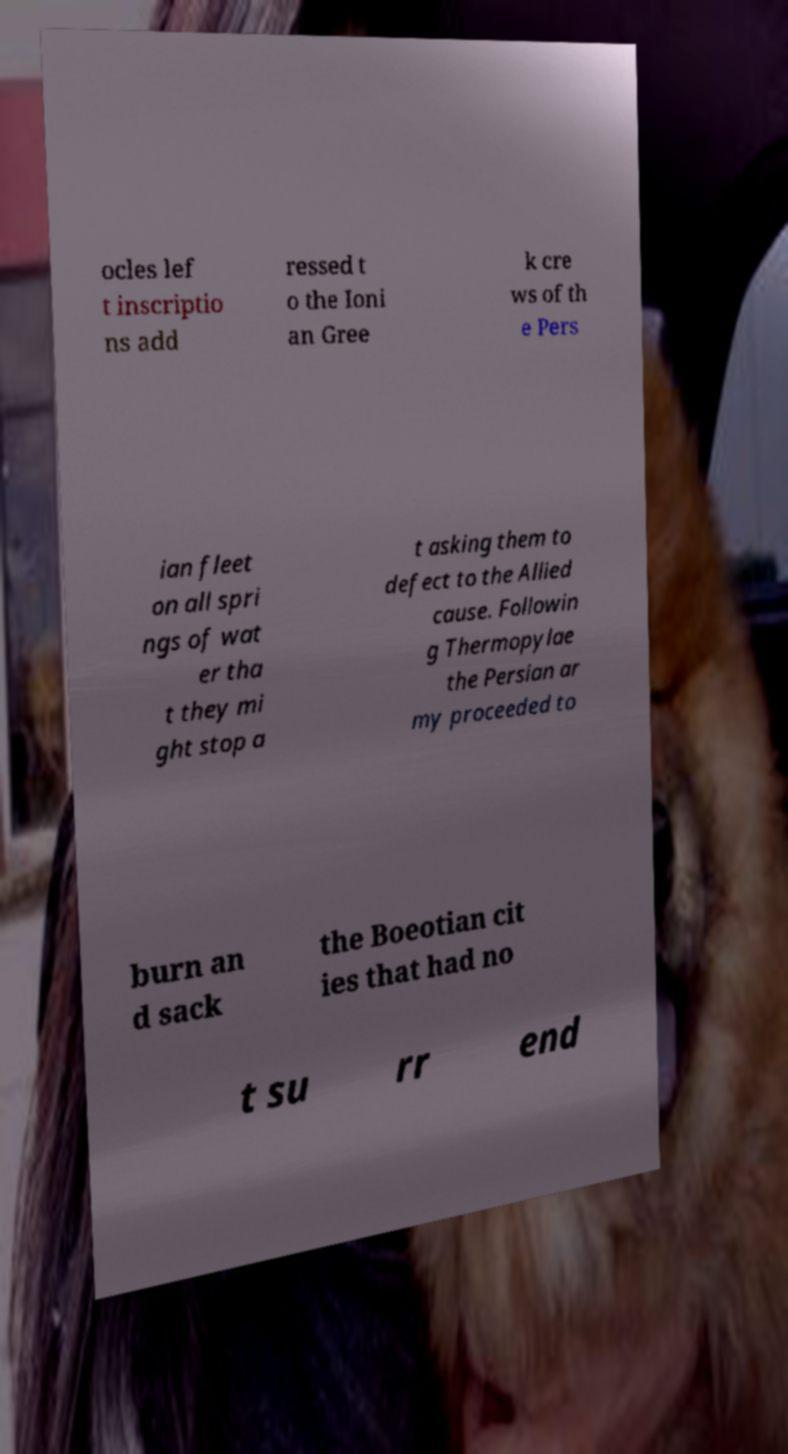I need the written content from this picture converted into text. Can you do that? ocles lef t inscriptio ns add ressed t o the Ioni an Gree k cre ws of th e Pers ian fleet on all spri ngs of wat er tha t they mi ght stop a t asking them to defect to the Allied cause. Followin g Thermopylae the Persian ar my proceeded to burn an d sack the Boeotian cit ies that had no t su rr end 